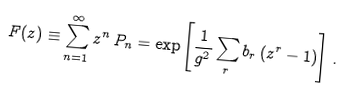<formula> <loc_0><loc_0><loc_500><loc_500>F ( z ) \equiv \sum _ { n = 1 } ^ { \infty } z ^ { n } \, P _ { n } = \exp \left [ \frac { 1 } { g ^ { 2 } } \sum _ { r } b _ { r } \left ( z ^ { r } - 1 \right ) \right ] \, .</formula> 